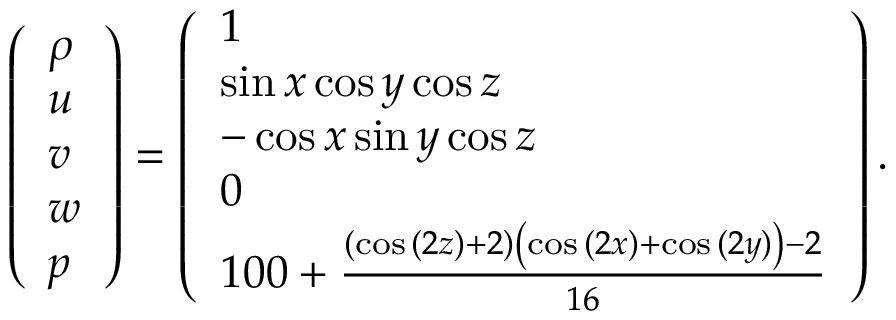Convert formula to latex. <formula><loc_0><loc_0><loc_500><loc_500>\left ( \begin{array} { l } { \rho } \\ { u } \\ { v } \\ { w } \\ { p } \end{array} \right ) = \left ( \begin{array} { l } { 1 } \\ { \sin { x } \cos { y } \cos { z } } \\ { - \cos { x } \sin { y } \cos { z } } \\ { 0 } \\ { 1 0 0 + \frac { \left ( \cos { ( 2 z ) } + 2 \right ) \left ( \cos { ( 2 x ) } + \cos { ( 2 y ) } \right ) - 2 } { 1 6 } } \end{array} \right ) .</formula> 